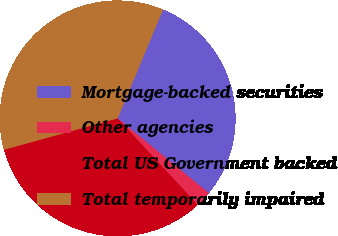<chart> <loc_0><loc_0><loc_500><loc_500><pie_chart><fcel>Mortgage-backed securities<fcel>Other agencies<fcel>Total US Government backed<fcel>Total temporarily impaired<nl><fcel>29.63%<fcel>2.2%<fcel>32.6%<fcel>35.57%<nl></chart> 